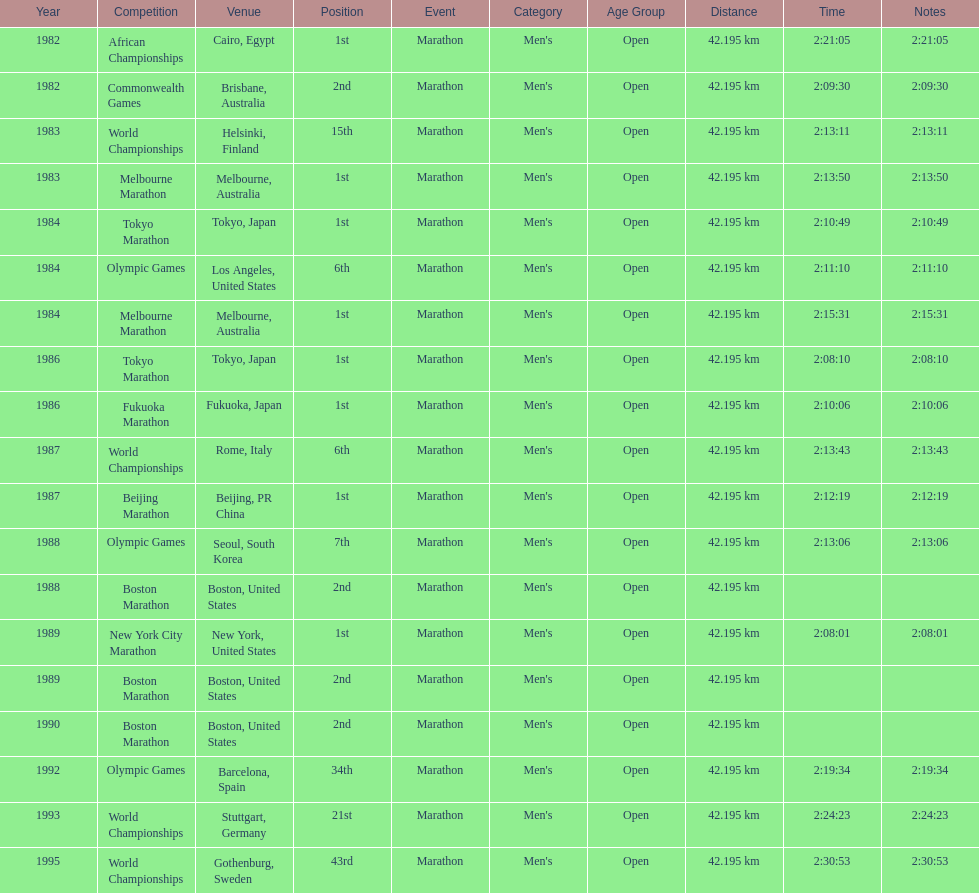What was the first marathon juma ikangaa won? 1982 African Championships. 